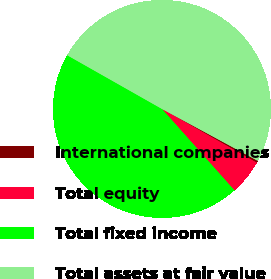Convert chart. <chart><loc_0><loc_0><loc_500><loc_500><pie_chart><fcel>International companies<fcel>Total equity<fcel>Total fixed income<fcel>Total assets at fair value<nl><fcel>0.3%<fcel>5.22%<fcel>44.78%<fcel>49.7%<nl></chart> 